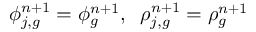Convert formula to latex. <formula><loc_0><loc_0><loc_500><loc_500>\phi _ { j , g } ^ { n + 1 } = \phi _ { g } ^ { n + 1 } , \, \rho _ { j , g } ^ { n + 1 } = \rho _ { g } ^ { n + 1 }</formula> 